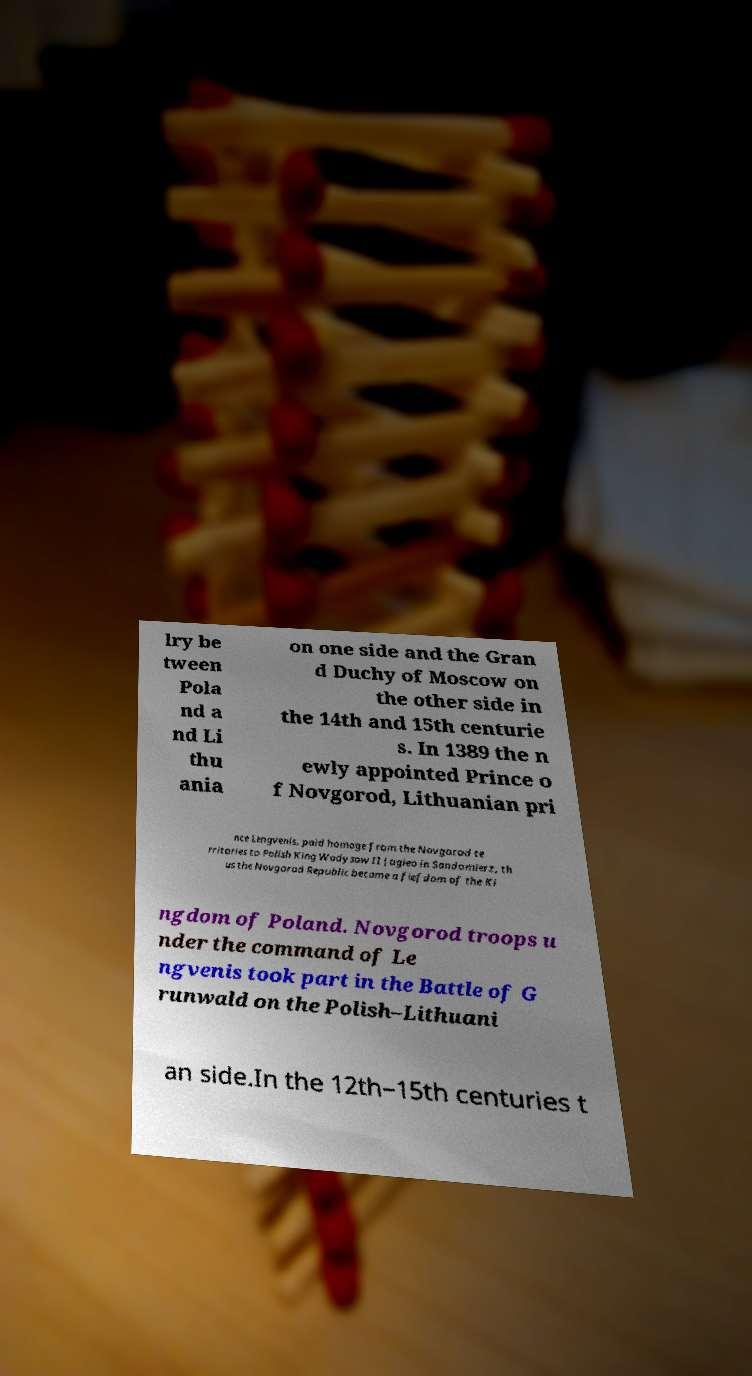Please read and relay the text visible in this image. What does it say? lry be tween Pola nd a nd Li thu ania on one side and the Gran d Duchy of Moscow on the other side in the 14th and 15th centurie s. In 1389 the n ewly appointed Prince o f Novgorod, Lithuanian pri nce Lengvenis, paid homage from the Novgorod te rritories to Polish King Wadysaw II Jagieo in Sandomierz, th us the Novgorod Republic became a fiefdom of the Ki ngdom of Poland. Novgorod troops u nder the command of Le ngvenis took part in the Battle of G runwald on the Polish–Lithuani an side.In the 12th–15th centuries t 